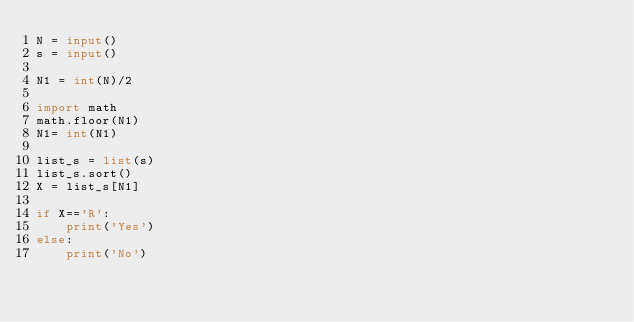<code> <loc_0><loc_0><loc_500><loc_500><_Python_>N = input()
s = input()

N1 = int(N)/2

import math
math.floor(N1)
N1= int(N1)

list_s = list(s)
list_s.sort()
X = list_s[N1]

if X=='R':
    print('Yes')
else:
    print('No')</code> 